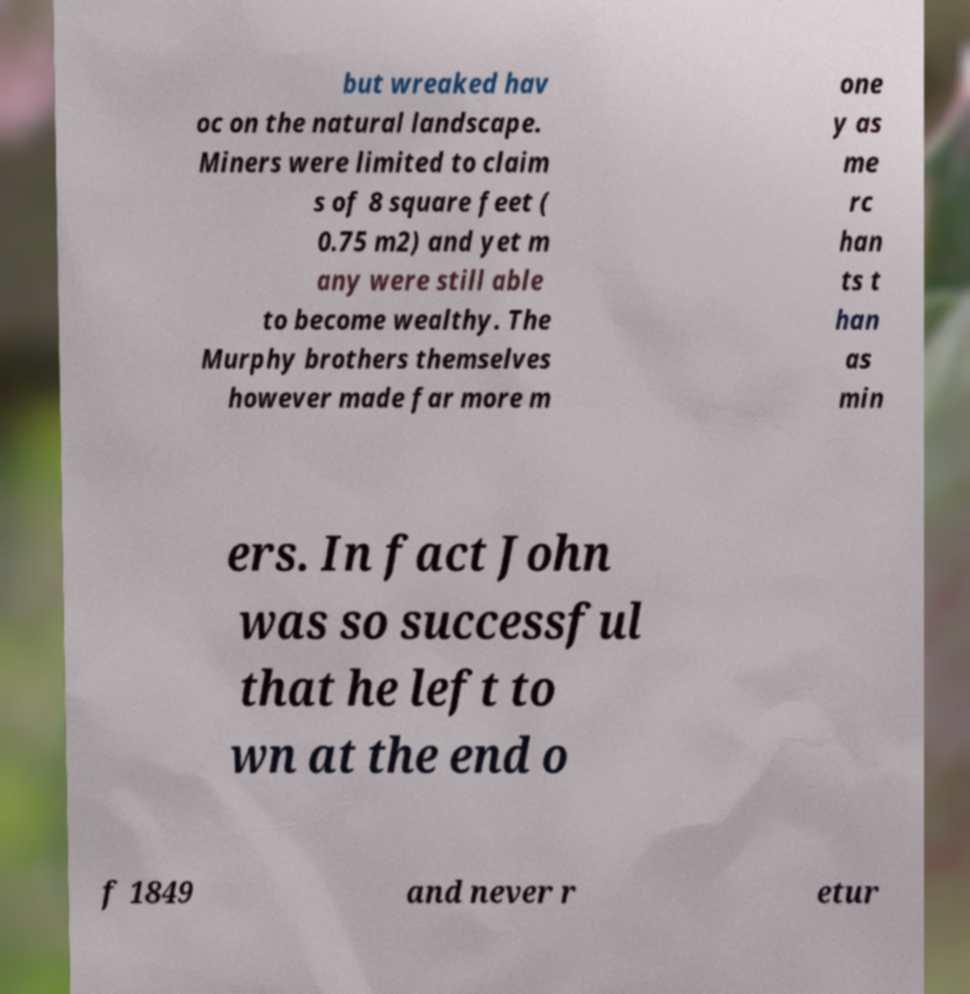There's text embedded in this image that I need extracted. Can you transcribe it verbatim? but wreaked hav oc on the natural landscape. Miners were limited to claim s of 8 square feet ( 0.75 m2) and yet m any were still able to become wealthy. The Murphy brothers themselves however made far more m one y as me rc han ts t han as min ers. In fact John was so successful that he left to wn at the end o f 1849 and never r etur 